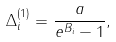Convert formula to latex. <formula><loc_0><loc_0><loc_500><loc_500>\Delta ^ { ( 1 ) } _ { i } = \frac { a } { e ^ { B _ { i } } - 1 } ,</formula> 